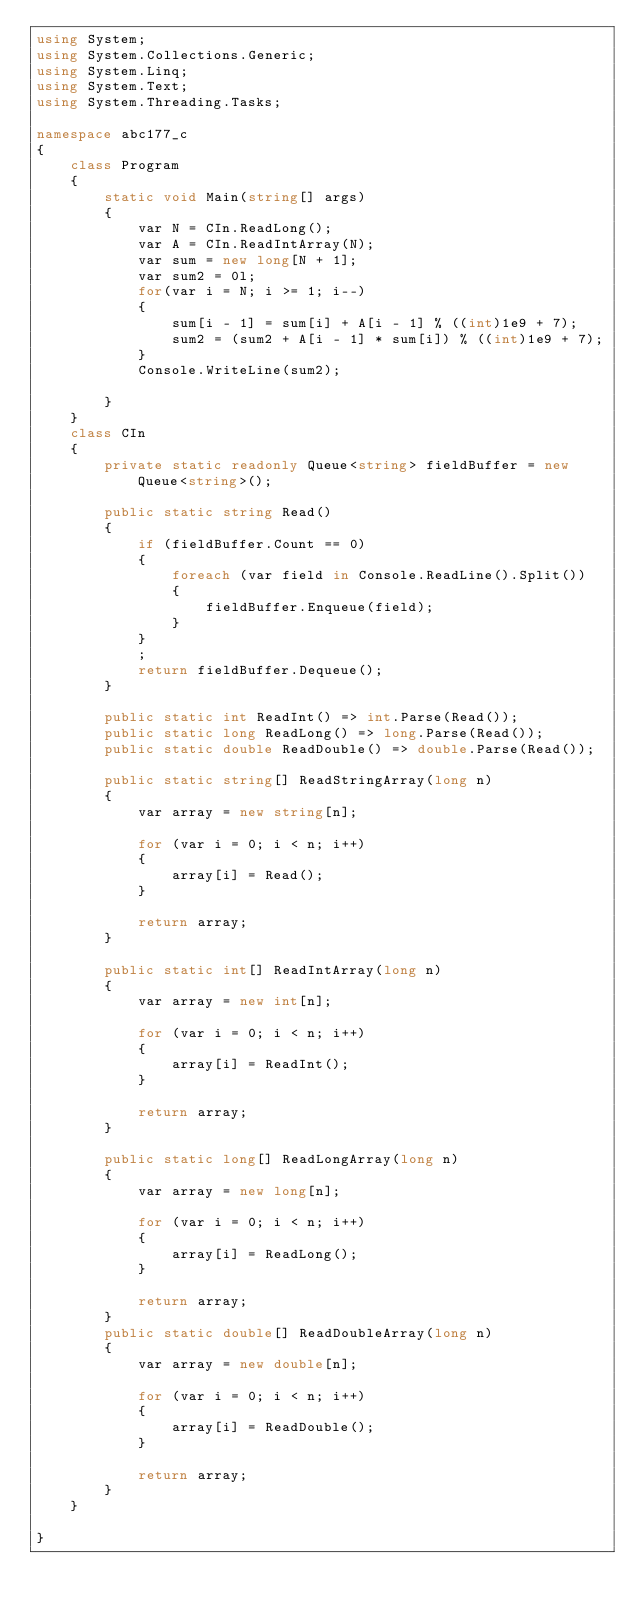Convert code to text. <code><loc_0><loc_0><loc_500><loc_500><_C#_>using System;
using System.Collections.Generic;
using System.Linq;
using System.Text;
using System.Threading.Tasks;

namespace abc177_c
{
    class Program
    {
        static void Main(string[] args)
        {
            var N = CIn.ReadLong();
            var A = CIn.ReadIntArray(N);
            var sum = new long[N + 1];
            var sum2 = 0l;
            for(var i = N; i >= 1; i--)
            {
                sum[i - 1] = sum[i] + A[i - 1] % ((int)1e9 + 7);
                sum2 = (sum2 + A[i - 1] * sum[i]) % ((int)1e9 + 7);
            }
            Console.WriteLine(sum2);
            
        }
    }
    class CIn
    {
        private static readonly Queue<string> fieldBuffer = new Queue<string>();

        public static string Read()
        {
            if (fieldBuffer.Count == 0)
            {
                foreach (var field in Console.ReadLine().Split())
                {
                    fieldBuffer.Enqueue(field);
                }
            }
            ;
            return fieldBuffer.Dequeue();
        }

        public static int ReadInt() => int.Parse(Read());
        public static long ReadLong() => long.Parse(Read());
        public static double ReadDouble() => double.Parse(Read());

        public static string[] ReadStringArray(long n)
        {
            var array = new string[n];

            for (var i = 0; i < n; i++)
            {
                array[i] = Read();
            }

            return array;
        }

        public static int[] ReadIntArray(long n)
        {
            var array = new int[n];

            for (var i = 0; i < n; i++)
            {
                array[i] = ReadInt();
            }

            return array;
        }

        public static long[] ReadLongArray(long n)
        {
            var array = new long[n];

            for (var i = 0; i < n; i++)
            {
                array[i] = ReadLong();
            }

            return array;
        }
        public static double[] ReadDoubleArray(long n)
        {
            var array = new double[n];

            for (var i = 0; i < n; i++)
            {
                array[i] = ReadDouble();
            }

            return array;
        }
    }

}
</code> 